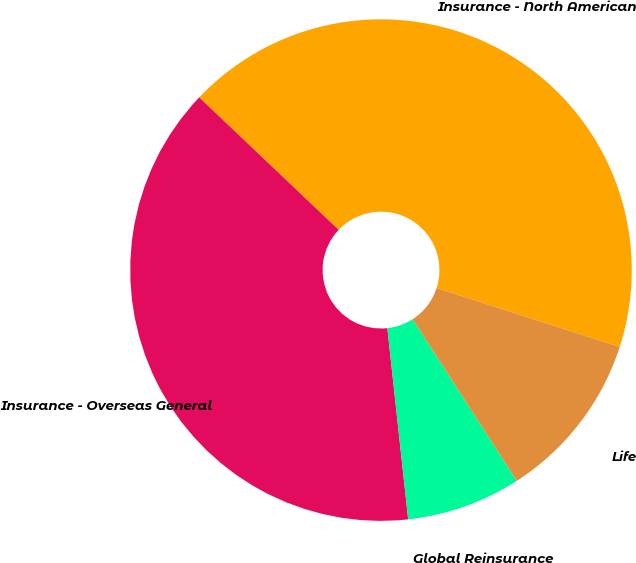Convert chart to OTSL. <chart><loc_0><loc_0><loc_500><loc_500><pie_chart><fcel>Insurance - North American<fcel>Insurance - Overseas General<fcel>Global Reinsurance<fcel>Life<nl><fcel>42.87%<fcel>38.82%<fcel>7.38%<fcel>10.93%<nl></chart> 